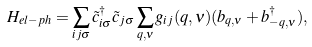Convert formula to latex. <formula><loc_0><loc_0><loc_500><loc_500>H _ { e l - p h } = \sum _ { i j \sigma } \tilde { c } _ { i \sigma } ^ { \dagger } \tilde { c } _ { j \sigma } \sum _ { { q } , \nu } g _ { i j } ( { q } , \nu ) ( b _ { { q } , \nu } + b _ { - { q } , \nu } ^ { \dagger } ) ,</formula> 